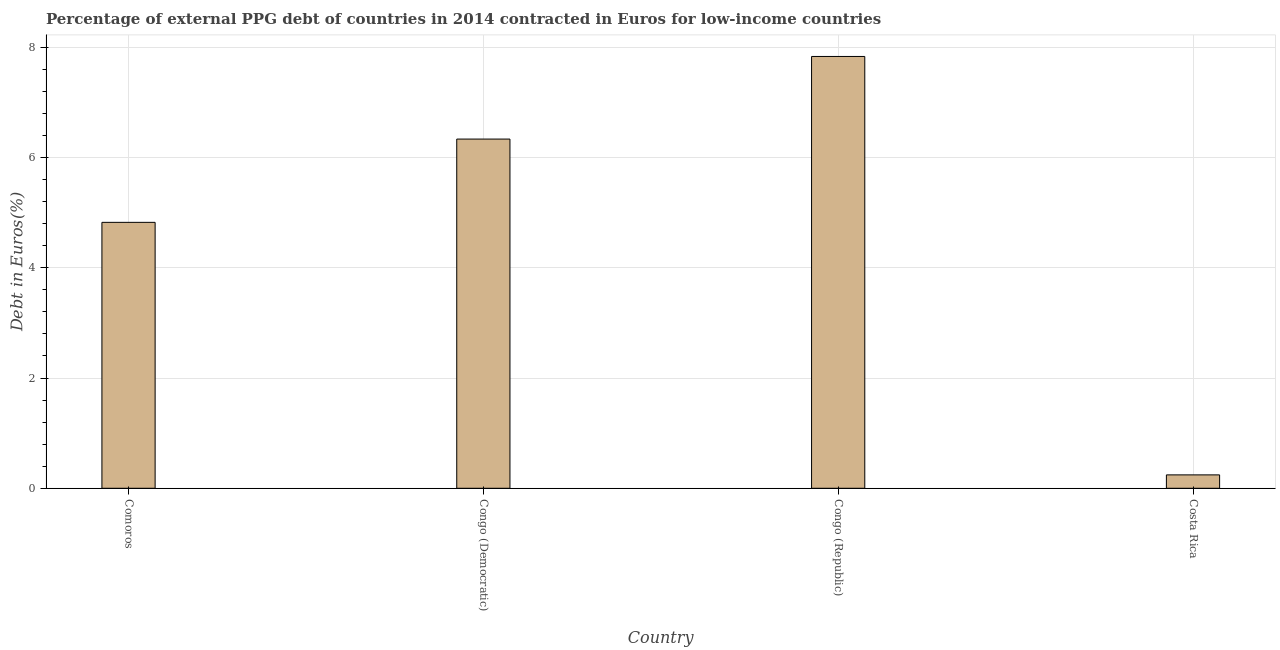Does the graph contain any zero values?
Provide a short and direct response. No. What is the title of the graph?
Your answer should be very brief. Percentage of external PPG debt of countries in 2014 contracted in Euros for low-income countries. What is the label or title of the Y-axis?
Your answer should be very brief. Debt in Euros(%). What is the currency composition of ppg debt in Comoros?
Give a very brief answer. 4.82. Across all countries, what is the maximum currency composition of ppg debt?
Your answer should be very brief. 7.83. Across all countries, what is the minimum currency composition of ppg debt?
Offer a very short reply. 0.24. In which country was the currency composition of ppg debt maximum?
Offer a very short reply. Congo (Republic). What is the sum of the currency composition of ppg debt?
Ensure brevity in your answer.  19.23. What is the difference between the currency composition of ppg debt in Congo (Republic) and Costa Rica?
Provide a succinct answer. 7.59. What is the average currency composition of ppg debt per country?
Provide a succinct answer. 4.81. What is the median currency composition of ppg debt?
Ensure brevity in your answer.  5.58. What is the ratio of the currency composition of ppg debt in Comoros to that in Congo (Democratic)?
Your answer should be very brief. 0.76. What is the difference between the highest and the second highest currency composition of ppg debt?
Your answer should be very brief. 1.5. Is the sum of the currency composition of ppg debt in Congo (Democratic) and Congo (Republic) greater than the maximum currency composition of ppg debt across all countries?
Give a very brief answer. Yes. What is the difference between the highest and the lowest currency composition of ppg debt?
Ensure brevity in your answer.  7.59. How many bars are there?
Ensure brevity in your answer.  4. How many countries are there in the graph?
Provide a succinct answer. 4. What is the Debt in Euros(%) in Comoros?
Keep it short and to the point. 4.82. What is the Debt in Euros(%) of Congo (Democratic)?
Provide a succinct answer. 6.33. What is the Debt in Euros(%) in Congo (Republic)?
Your answer should be very brief. 7.83. What is the Debt in Euros(%) in Costa Rica?
Give a very brief answer. 0.24. What is the difference between the Debt in Euros(%) in Comoros and Congo (Democratic)?
Offer a terse response. -1.51. What is the difference between the Debt in Euros(%) in Comoros and Congo (Republic)?
Make the answer very short. -3.01. What is the difference between the Debt in Euros(%) in Comoros and Costa Rica?
Provide a short and direct response. 4.58. What is the difference between the Debt in Euros(%) in Congo (Democratic) and Congo (Republic)?
Keep it short and to the point. -1.5. What is the difference between the Debt in Euros(%) in Congo (Democratic) and Costa Rica?
Keep it short and to the point. 6.09. What is the difference between the Debt in Euros(%) in Congo (Republic) and Costa Rica?
Ensure brevity in your answer.  7.59. What is the ratio of the Debt in Euros(%) in Comoros to that in Congo (Democratic)?
Keep it short and to the point. 0.76. What is the ratio of the Debt in Euros(%) in Comoros to that in Congo (Republic)?
Offer a very short reply. 0.62. What is the ratio of the Debt in Euros(%) in Comoros to that in Costa Rica?
Give a very brief answer. 19.85. What is the ratio of the Debt in Euros(%) in Congo (Democratic) to that in Congo (Republic)?
Your answer should be very brief. 0.81. What is the ratio of the Debt in Euros(%) in Congo (Democratic) to that in Costa Rica?
Ensure brevity in your answer.  26.07. What is the ratio of the Debt in Euros(%) in Congo (Republic) to that in Costa Rica?
Your answer should be very brief. 32.23. 